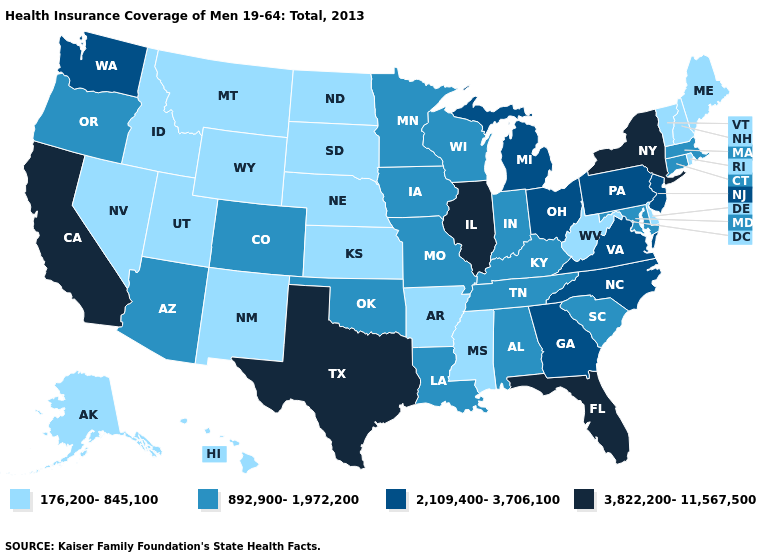Name the states that have a value in the range 3,822,200-11,567,500?
Write a very short answer. California, Florida, Illinois, New York, Texas. What is the lowest value in the Northeast?
Keep it brief. 176,200-845,100. Name the states that have a value in the range 3,822,200-11,567,500?
Short answer required. California, Florida, Illinois, New York, Texas. Which states have the lowest value in the USA?
Write a very short answer. Alaska, Arkansas, Delaware, Hawaii, Idaho, Kansas, Maine, Mississippi, Montana, Nebraska, Nevada, New Hampshire, New Mexico, North Dakota, Rhode Island, South Dakota, Utah, Vermont, West Virginia, Wyoming. Name the states that have a value in the range 176,200-845,100?
Give a very brief answer. Alaska, Arkansas, Delaware, Hawaii, Idaho, Kansas, Maine, Mississippi, Montana, Nebraska, Nevada, New Hampshire, New Mexico, North Dakota, Rhode Island, South Dakota, Utah, Vermont, West Virginia, Wyoming. What is the lowest value in the Northeast?
Quick response, please. 176,200-845,100. Does New Hampshire have the lowest value in the USA?
Answer briefly. Yes. Does the map have missing data?
Write a very short answer. No. What is the value of New Mexico?
Keep it brief. 176,200-845,100. Among the states that border New Jersey , which have the lowest value?
Give a very brief answer. Delaware. Name the states that have a value in the range 2,109,400-3,706,100?
Keep it brief. Georgia, Michigan, New Jersey, North Carolina, Ohio, Pennsylvania, Virginia, Washington. Does Iowa have the lowest value in the USA?
Keep it brief. No. Which states hav the highest value in the West?
Answer briefly. California. Name the states that have a value in the range 892,900-1,972,200?
Quick response, please. Alabama, Arizona, Colorado, Connecticut, Indiana, Iowa, Kentucky, Louisiana, Maryland, Massachusetts, Minnesota, Missouri, Oklahoma, Oregon, South Carolina, Tennessee, Wisconsin. Which states hav the highest value in the West?
Keep it brief. California. 